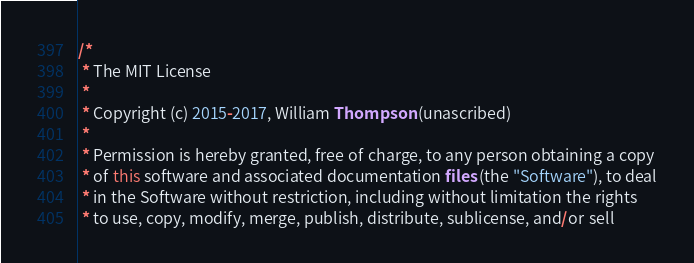<code> <loc_0><loc_0><loc_500><loc_500><_Java_>/*
 * The MIT License
 *
 * Copyright (c) 2015-2017, William Thompson (unascribed)
 *
 * Permission is hereby granted, free of charge, to any person obtaining a copy
 * of this software and associated documentation files (the "Software"), to deal
 * in the Software without restriction, including without limitation the rights
 * to use, copy, modify, merge, publish, distribute, sublicense, and/or sell</code> 